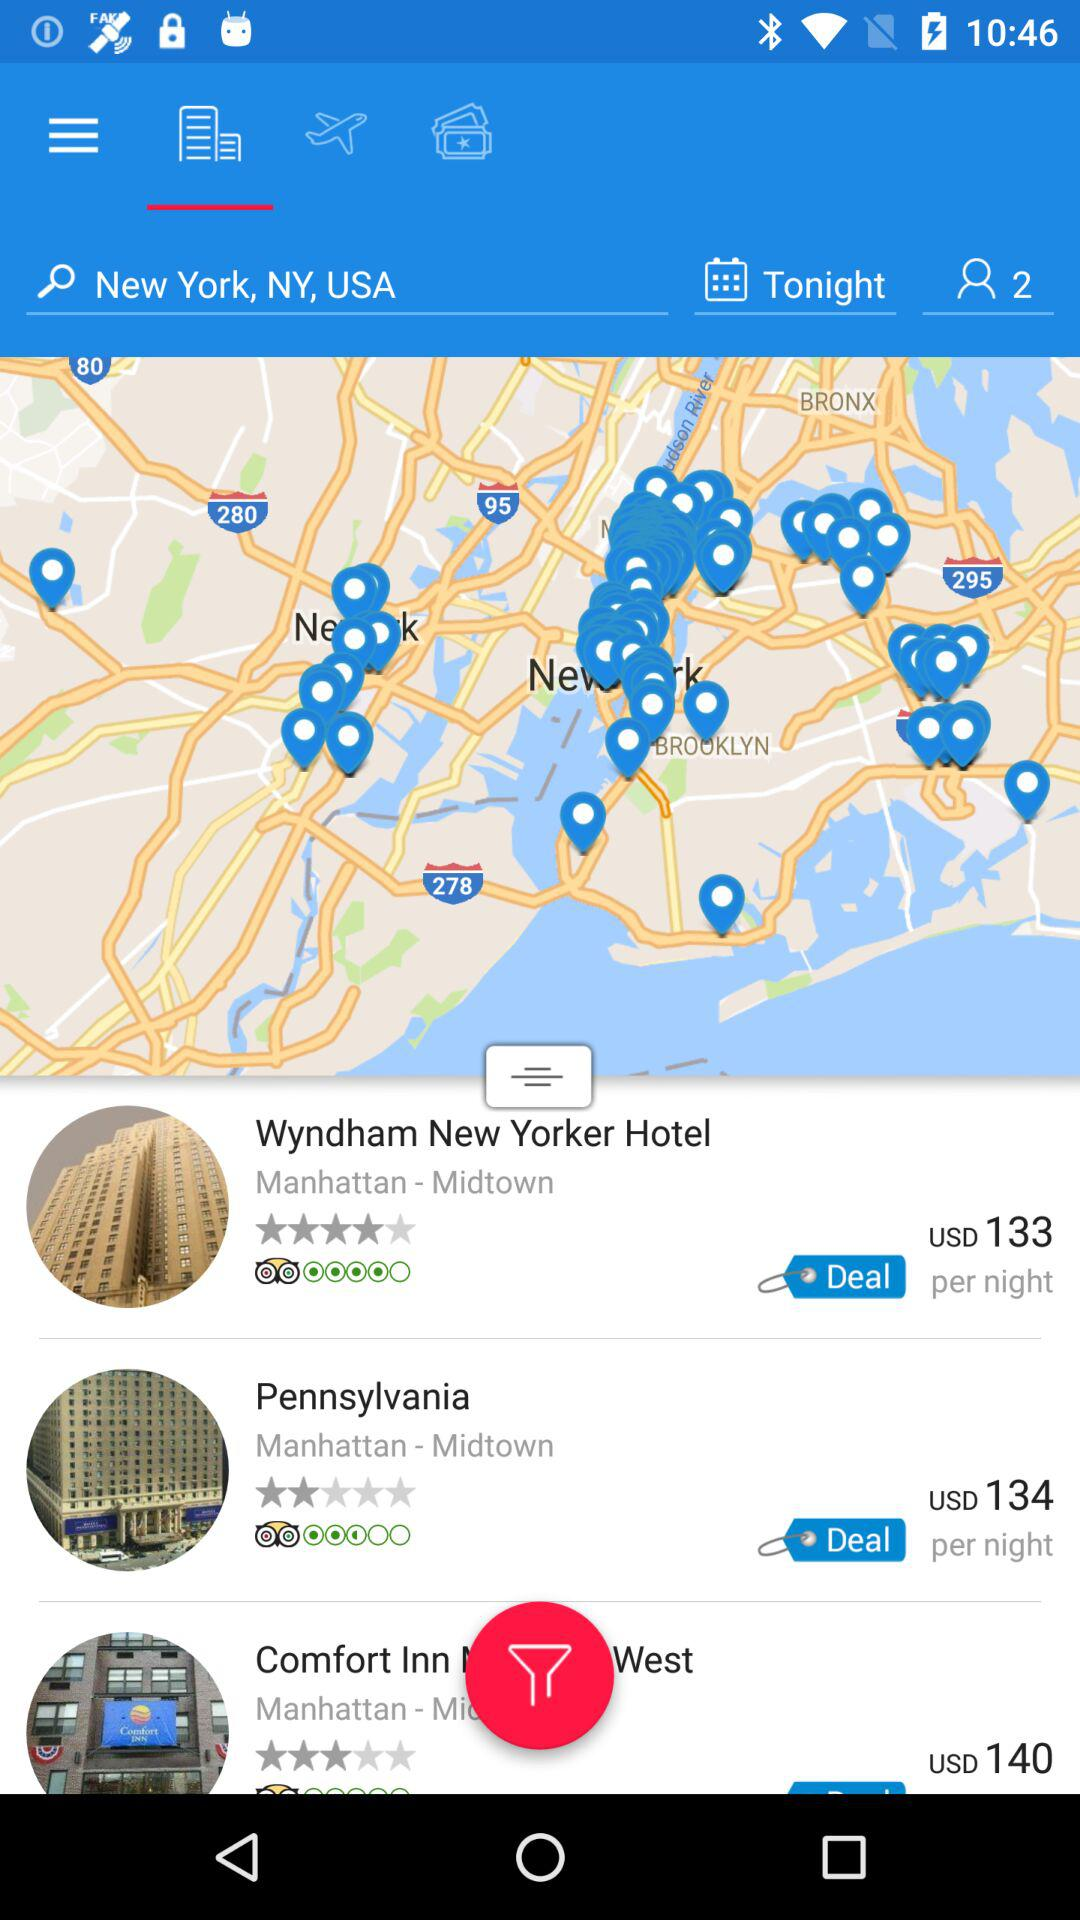What is the entered location? The entered location is New York, NY, USA. 